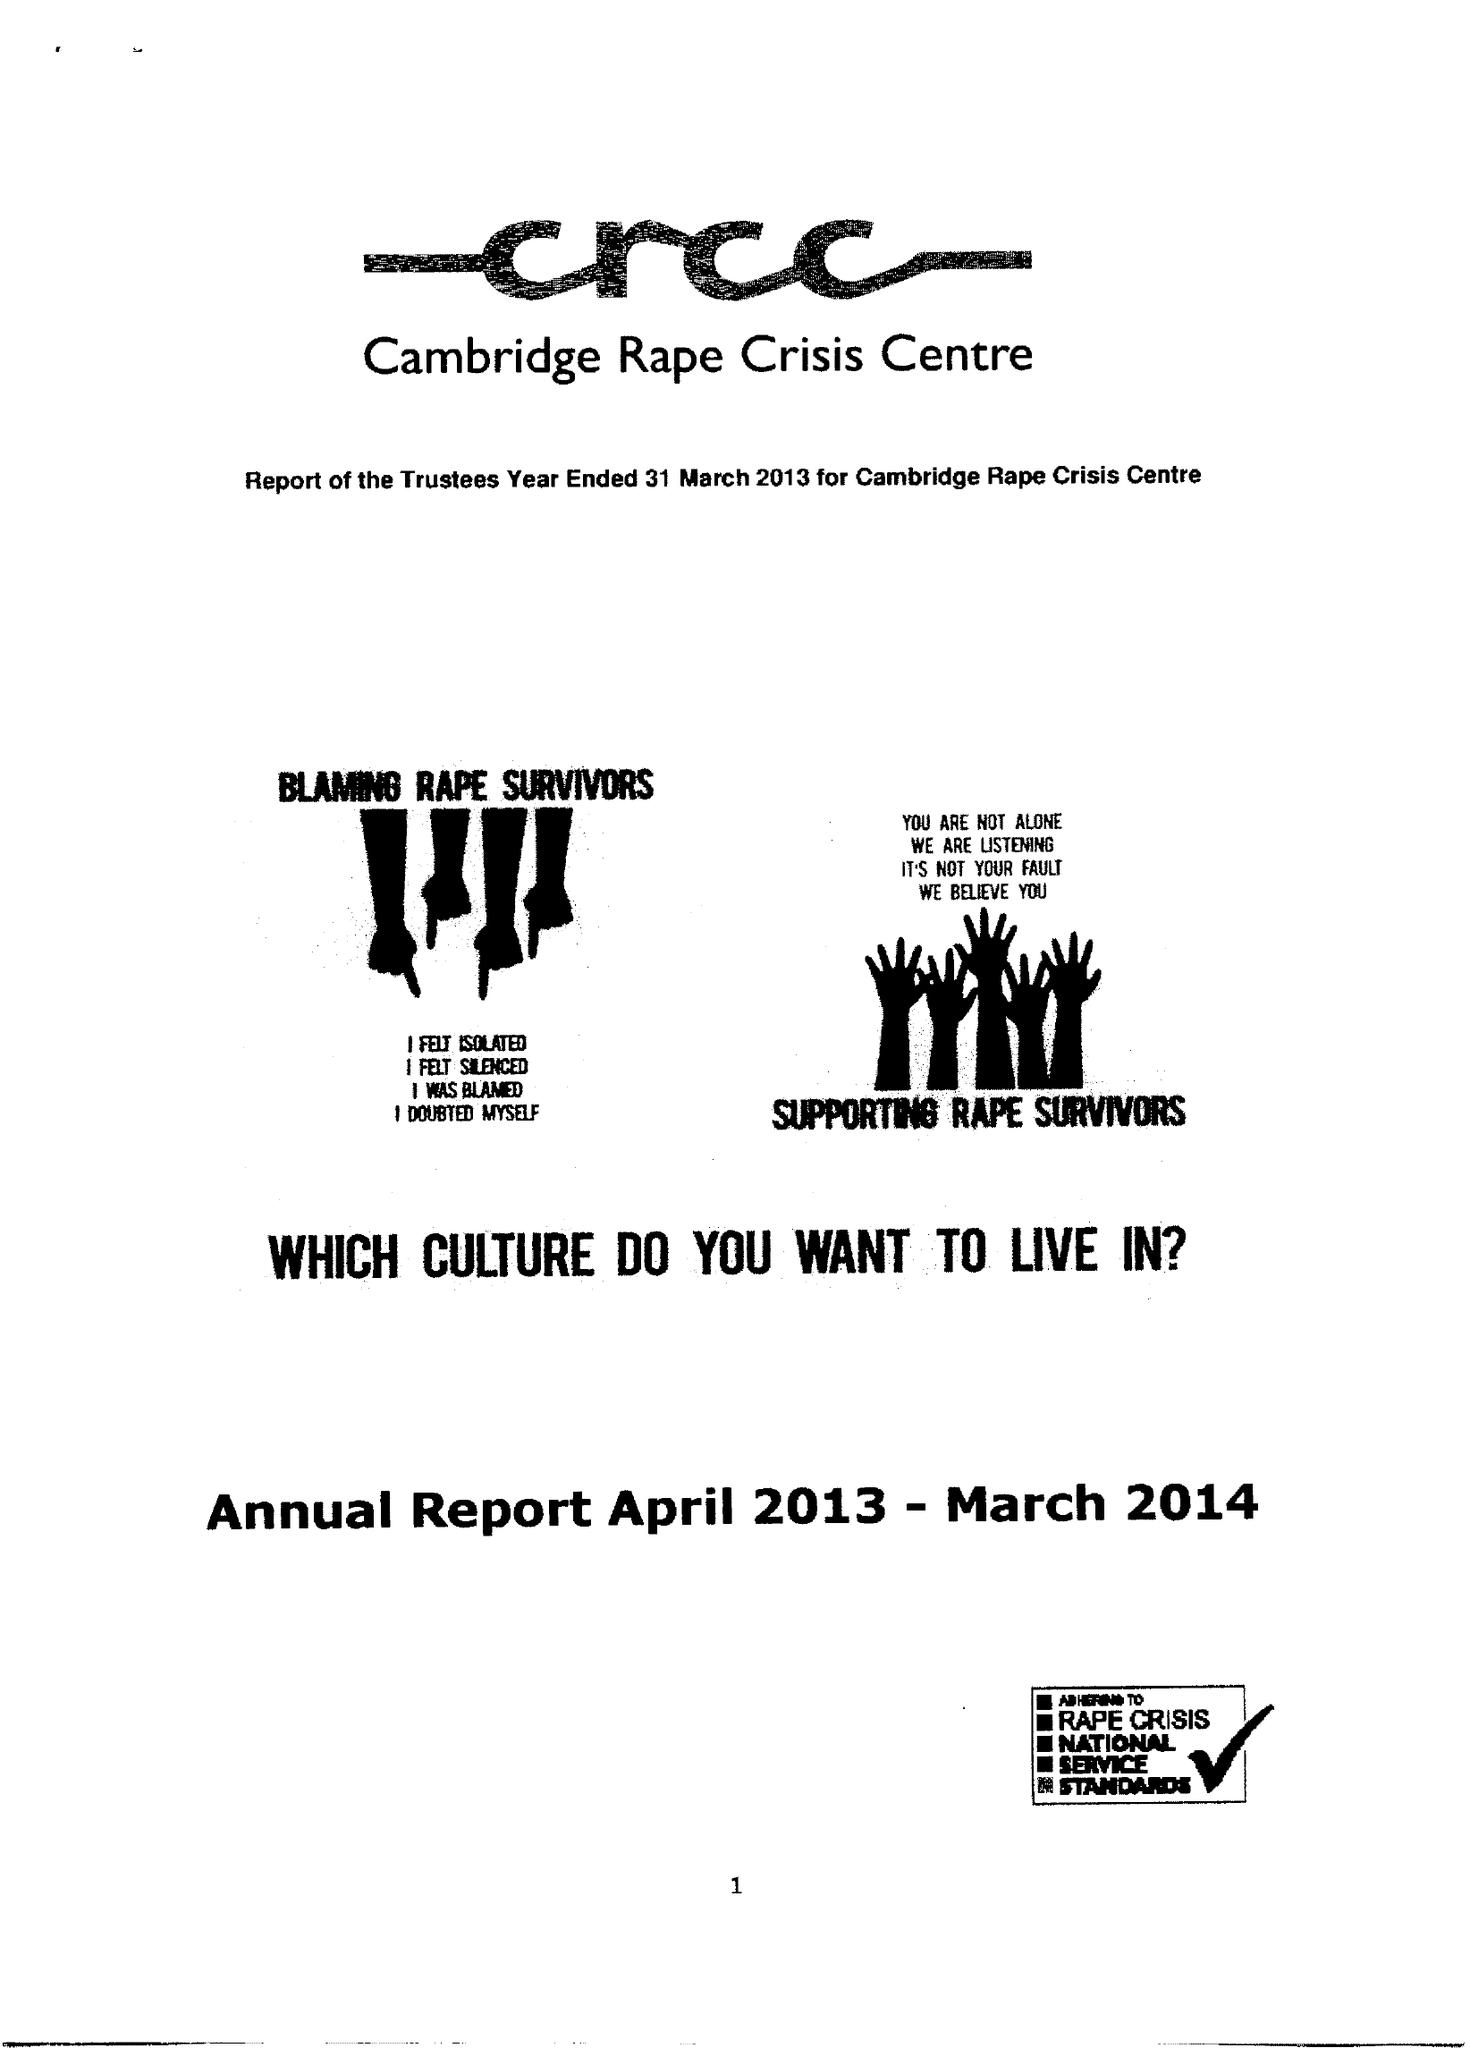What is the value for the address__post_town?
Answer the question using a single word or phrase. CAMBRIDGE 